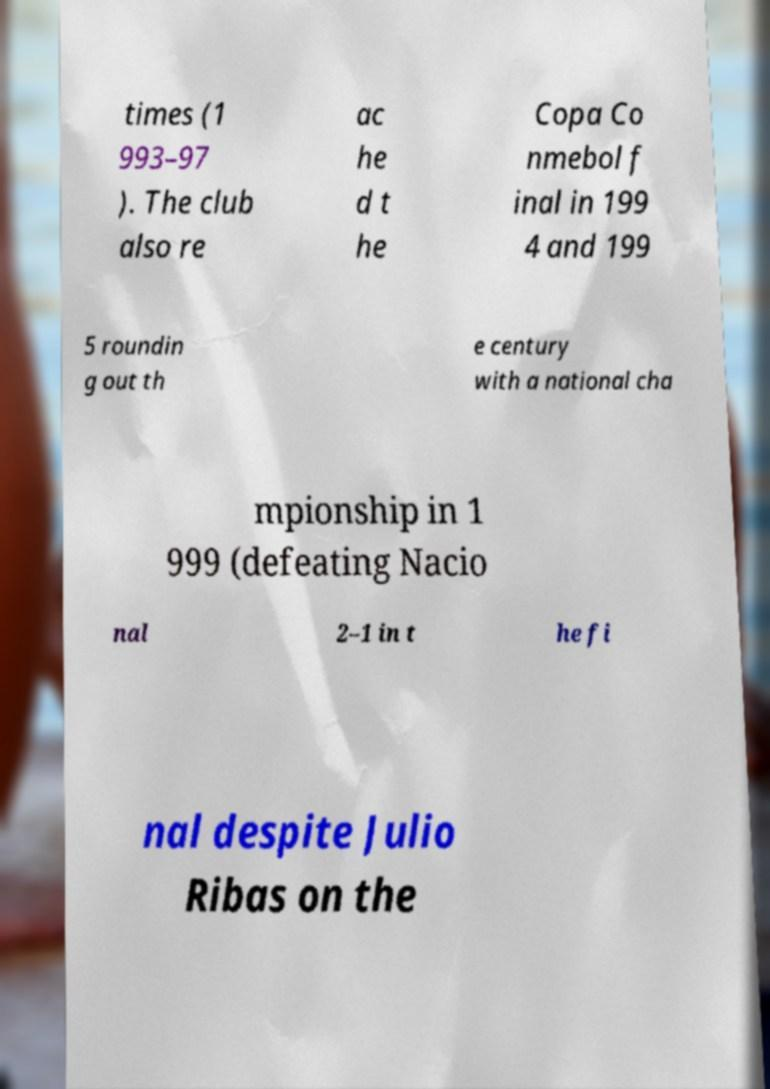Could you assist in decoding the text presented in this image and type it out clearly? times (1 993–97 ). The club also re ac he d t he Copa Co nmebol f inal in 199 4 and 199 5 roundin g out th e century with a national cha mpionship in 1 999 (defeating Nacio nal 2–1 in t he fi nal despite Julio Ribas on the 